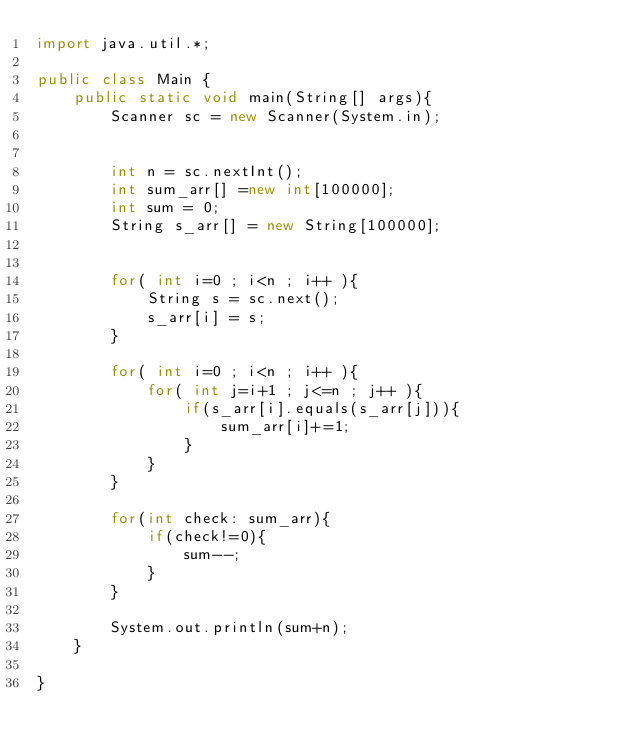Convert code to text. <code><loc_0><loc_0><loc_500><loc_500><_Java_>import java.util.*;

public class Main {
    public static void main(String[] args){
        Scanner sc = new Scanner(System.in);
 

        int n = sc.nextInt();
        int sum_arr[] =new int[100000];
        int sum = 0;
        String s_arr[] = new String[100000]; 

        
        for( int i=0 ; i<n ; i++ ){
            String s = sc.next(); 
            s_arr[i] = s;
        }

        for( int i=0 ; i<n ; i++ ){
            for( int j=i+1 ; j<=n ; j++ ){
                if(s_arr[i].equals(s_arr[j])){
                    sum_arr[i]+=1;
                } 
            }
        }

        for(int check: sum_arr){
            if(check!=0){
                sum--;
            }
        }

        System.out.println(sum+n);
    }
    
}</code> 